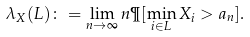Convert formula to latex. <formula><loc_0><loc_0><loc_500><loc_500>\lambda _ { X } ( L ) \colon = \lim _ { n \to \infty } n \P [ \min _ { i \in L } X _ { i } > a _ { n } ] .</formula> 